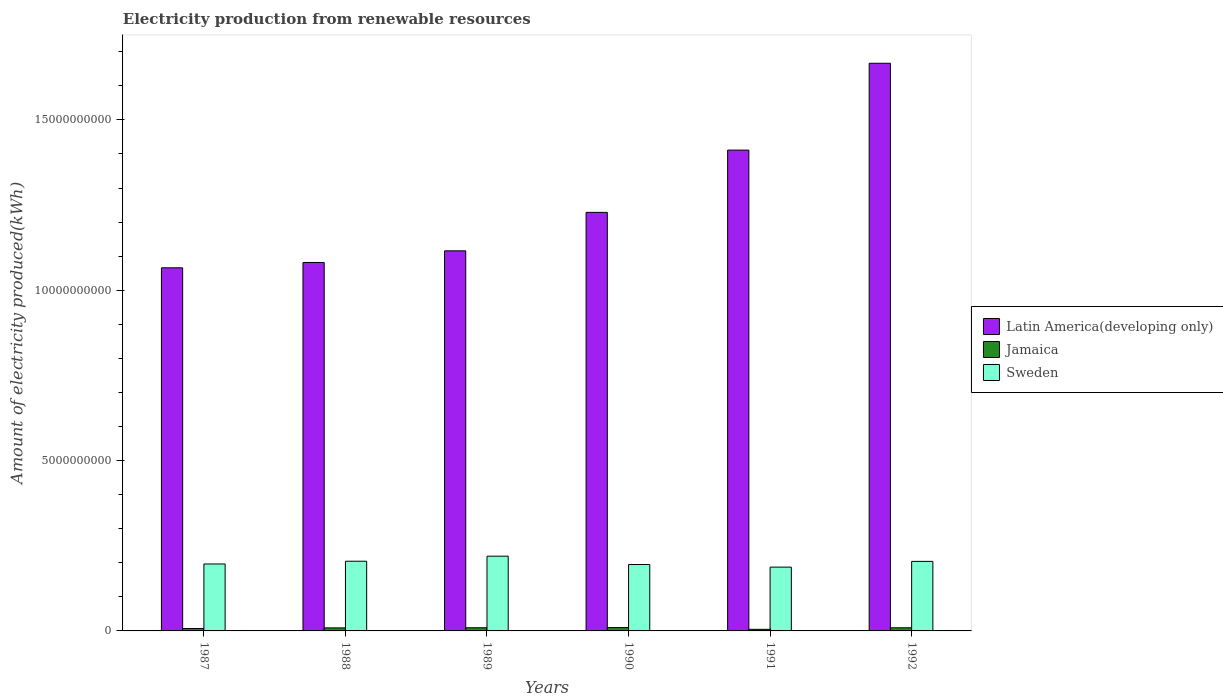Are the number of bars per tick equal to the number of legend labels?
Offer a very short reply. Yes. What is the label of the 3rd group of bars from the left?
Keep it short and to the point. 1989. In how many cases, is the number of bars for a given year not equal to the number of legend labels?
Your answer should be very brief. 0. What is the amount of electricity produced in Jamaica in 1987?
Offer a very short reply. 7.10e+07. Across all years, what is the maximum amount of electricity produced in Sweden?
Offer a very short reply. 2.19e+09. Across all years, what is the minimum amount of electricity produced in Jamaica?
Offer a very short reply. 4.70e+07. What is the total amount of electricity produced in Jamaica in the graph?
Offer a terse response. 4.90e+08. What is the difference between the amount of electricity produced in Sweden in 1988 and that in 1992?
Your response must be concise. 5.00e+06. What is the difference between the amount of electricity produced in Sweden in 1992 and the amount of electricity produced in Jamaica in 1987?
Make the answer very short. 1.97e+09. What is the average amount of electricity produced in Latin America(developing only) per year?
Offer a very short reply. 1.26e+1. In the year 1992, what is the difference between the amount of electricity produced in Latin America(developing only) and amount of electricity produced in Sweden?
Offer a very short reply. 1.46e+1. In how many years, is the amount of electricity produced in Sweden greater than 8000000000 kWh?
Keep it short and to the point. 0. What is the ratio of the amount of electricity produced in Sweden in 1989 to that in 1992?
Your response must be concise. 1.07. Is the amount of electricity produced in Jamaica in 1990 less than that in 1991?
Provide a short and direct response. No. What is the difference between the highest and the lowest amount of electricity produced in Latin America(developing only)?
Your answer should be compact. 6.00e+09. In how many years, is the amount of electricity produced in Jamaica greater than the average amount of electricity produced in Jamaica taken over all years?
Offer a terse response. 4. What does the 1st bar from the right in 1991 represents?
Your response must be concise. Sweden. What is the difference between two consecutive major ticks on the Y-axis?
Provide a short and direct response. 5.00e+09. Does the graph contain any zero values?
Give a very brief answer. No. How are the legend labels stacked?
Give a very brief answer. Vertical. What is the title of the graph?
Provide a succinct answer. Electricity production from renewable resources. What is the label or title of the X-axis?
Keep it short and to the point. Years. What is the label or title of the Y-axis?
Ensure brevity in your answer.  Amount of electricity produced(kWh). What is the Amount of electricity produced(kWh) in Latin America(developing only) in 1987?
Provide a short and direct response. 1.07e+1. What is the Amount of electricity produced(kWh) in Jamaica in 1987?
Offer a terse response. 7.10e+07. What is the Amount of electricity produced(kWh) of Sweden in 1987?
Make the answer very short. 1.96e+09. What is the Amount of electricity produced(kWh) of Latin America(developing only) in 1988?
Your answer should be very brief. 1.08e+1. What is the Amount of electricity produced(kWh) in Jamaica in 1988?
Offer a very short reply. 8.90e+07. What is the Amount of electricity produced(kWh) of Sweden in 1988?
Offer a terse response. 2.05e+09. What is the Amount of electricity produced(kWh) of Latin America(developing only) in 1989?
Give a very brief answer. 1.12e+1. What is the Amount of electricity produced(kWh) in Jamaica in 1989?
Provide a succinct answer. 9.30e+07. What is the Amount of electricity produced(kWh) of Sweden in 1989?
Your answer should be very brief. 2.19e+09. What is the Amount of electricity produced(kWh) of Latin America(developing only) in 1990?
Offer a very short reply. 1.23e+1. What is the Amount of electricity produced(kWh) of Jamaica in 1990?
Offer a terse response. 9.80e+07. What is the Amount of electricity produced(kWh) of Sweden in 1990?
Make the answer very short. 1.95e+09. What is the Amount of electricity produced(kWh) in Latin America(developing only) in 1991?
Offer a very short reply. 1.41e+1. What is the Amount of electricity produced(kWh) in Jamaica in 1991?
Your response must be concise. 4.70e+07. What is the Amount of electricity produced(kWh) in Sweden in 1991?
Your response must be concise. 1.87e+09. What is the Amount of electricity produced(kWh) of Latin America(developing only) in 1992?
Offer a very short reply. 1.67e+1. What is the Amount of electricity produced(kWh) in Jamaica in 1992?
Provide a short and direct response. 9.20e+07. What is the Amount of electricity produced(kWh) in Sweden in 1992?
Your response must be concise. 2.04e+09. Across all years, what is the maximum Amount of electricity produced(kWh) in Latin America(developing only)?
Ensure brevity in your answer.  1.67e+1. Across all years, what is the maximum Amount of electricity produced(kWh) in Jamaica?
Your response must be concise. 9.80e+07. Across all years, what is the maximum Amount of electricity produced(kWh) in Sweden?
Provide a short and direct response. 2.19e+09. Across all years, what is the minimum Amount of electricity produced(kWh) in Latin America(developing only)?
Make the answer very short. 1.07e+1. Across all years, what is the minimum Amount of electricity produced(kWh) of Jamaica?
Give a very brief answer. 4.70e+07. Across all years, what is the minimum Amount of electricity produced(kWh) of Sweden?
Your answer should be very brief. 1.87e+09. What is the total Amount of electricity produced(kWh) of Latin America(developing only) in the graph?
Your response must be concise. 7.57e+1. What is the total Amount of electricity produced(kWh) of Jamaica in the graph?
Make the answer very short. 4.90e+08. What is the total Amount of electricity produced(kWh) of Sweden in the graph?
Offer a very short reply. 1.21e+1. What is the difference between the Amount of electricity produced(kWh) in Latin America(developing only) in 1987 and that in 1988?
Your response must be concise. -1.56e+08. What is the difference between the Amount of electricity produced(kWh) in Jamaica in 1987 and that in 1988?
Give a very brief answer. -1.80e+07. What is the difference between the Amount of electricity produced(kWh) of Sweden in 1987 and that in 1988?
Provide a succinct answer. -8.10e+07. What is the difference between the Amount of electricity produced(kWh) in Latin America(developing only) in 1987 and that in 1989?
Your answer should be very brief. -4.98e+08. What is the difference between the Amount of electricity produced(kWh) of Jamaica in 1987 and that in 1989?
Offer a very short reply. -2.20e+07. What is the difference between the Amount of electricity produced(kWh) of Sweden in 1987 and that in 1989?
Offer a very short reply. -2.29e+08. What is the difference between the Amount of electricity produced(kWh) of Latin America(developing only) in 1987 and that in 1990?
Ensure brevity in your answer.  -1.63e+09. What is the difference between the Amount of electricity produced(kWh) in Jamaica in 1987 and that in 1990?
Your response must be concise. -2.70e+07. What is the difference between the Amount of electricity produced(kWh) of Sweden in 1987 and that in 1990?
Keep it short and to the point. 1.60e+07. What is the difference between the Amount of electricity produced(kWh) of Latin America(developing only) in 1987 and that in 1991?
Provide a short and direct response. -3.46e+09. What is the difference between the Amount of electricity produced(kWh) of Jamaica in 1987 and that in 1991?
Ensure brevity in your answer.  2.40e+07. What is the difference between the Amount of electricity produced(kWh) in Sweden in 1987 and that in 1991?
Offer a very short reply. 9.20e+07. What is the difference between the Amount of electricity produced(kWh) in Latin America(developing only) in 1987 and that in 1992?
Your answer should be very brief. -6.00e+09. What is the difference between the Amount of electricity produced(kWh) of Jamaica in 1987 and that in 1992?
Your response must be concise. -2.10e+07. What is the difference between the Amount of electricity produced(kWh) in Sweden in 1987 and that in 1992?
Your answer should be very brief. -7.60e+07. What is the difference between the Amount of electricity produced(kWh) of Latin America(developing only) in 1988 and that in 1989?
Your answer should be compact. -3.42e+08. What is the difference between the Amount of electricity produced(kWh) of Jamaica in 1988 and that in 1989?
Offer a terse response. -4.00e+06. What is the difference between the Amount of electricity produced(kWh) of Sweden in 1988 and that in 1989?
Your answer should be compact. -1.48e+08. What is the difference between the Amount of electricity produced(kWh) in Latin America(developing only) in 1988 and that in 1990?
Give a very brief answer. -1.47e+09. What is the difference between the Amount of electricity produced(kWh) of Jamaica in 1988 and that in 1990?
Offer a very short reply. -9.00e+06. What is the difference between the Amount of electricity produced(kWh) of Sweden in 1988 and that in 1990?
Your answer should be very brief. 9.70e+07. What is the difference between the Amount of electricity produced(kWh) of Latin America(developing only) in 1988 and that in 1991?
Offer a very short reply. -3.30e+09. What is the difference between the Amount of electricity produced(kWh) in Jamaica in 1988 and that in 1991?
Your answer should be very brief. 4.20e+07. What is the difference between the Amount of electricity produced(kWh) of Sweden in 1988 and that in 1991?
Provide a short and direct response. 1.73e+08. What is the difference between the Amount of electricity produced(kWh) in Latin America(developing only) in 1988 and that in 1992?
Your answer should be compact. -5.85e+09. What is the difference between the Amount of electricity produced(kWh) of Jamaica in 1988 and that in 1992?
Give a very brief answer. -3.00e+06. What is the difference between the Amount of electricity produced(kWh) of Latin America(developing only) in 1989 and that in 1990?
Give a very brief answer. -1.13e+09. What is the difference between the Amount of electricity produced(kWh) in Jamaica in 1989 and that in 1990?
Provide a succinct answer. -5.00e+06. What is the difference between the Amount of electricity produced(kWh) in Sweden in 1989 and that in 1990?
Offer a terse response. 2.45e+08. What is the difference between the Amount of electricity produced(kWh) of Latin America(developing only) in 1989 and that in 1991?
Provide a short and direct response. -2.96e+09. What is the difference between the Amount of electricity produced(kWh) in Jamaica in 1989 and that in 1991?
Provide a short and direct response. 4.60e+07. What is the difference between the Amount of electricity produced(kWh) in Sweden in 1989 and that in 1991?
Make the answer very short. 3.21e+08. What is the difference between the Amount of electricity produced(kWh) in Latin America(developing only) in 1989 and that in 1992?
Provide a succinct answer. -5.51e+09. What is the difference between the Amount of electricity produced(kWh) in Jamaica in 1989 and that in 1992?
Offer a very short reply. 1.00e+06. What is the difference between the Amount of electricity produced(kWh) in Sweden in 1989 and that in 1992?
Provide a succinct answer. 1.53e+08. What is the difference between the Amount of electricity produced(kWh) of Latin America(developing only) in 1990 and that in 1991?
Provide a short and direct response. -1.83e+09. What is the difference between the Amount of electricity produced(kWh) in Jamaica in 1990 and that in 1991?
Your answer should be compact. 5.10e+07. What is the difference between the Amount of electricity produced(kWh) of Sweden in 1990 and that in 1991?
Make the answer very short. 7.60e+07. What is the difference between the Amount of electricity produced(kWh) of Latin America(developing only) in 1990 and that in 1992?
Keep it short and to the point. -4.38e+09. What is the difference between the Amount of electricity produced(kWh) of Sweden in 1990 and that in 1992?
Your answer should be compact. -9.20e+07. What is the difference between the Amount of electricity produced(kWh) of Latin America(developing only) in 1991 and that in 1992?
Ensure brevity in your answer.  -2.55e+09. What is the difference between the Amount of electricity produced(kWh) of Jamaica in 1991 and that in 1992?
Provide a short and direct response. -4.50e+07. What is the difference between the Amount of electricity produced(kWh) of Sweden in 1991 and that in 1992?
Make the answer very short. -1.68e+08. What is the difference between the Amount of electricity produced(kWh) of Latin America(developing only) in 1987 and the Amount of electricity produced(kWh) of Jamaica in 1988?
Your answer should be very brief. 1.06e+1. What is the difference between the Amount of electricity produced(kWh) in Latin America(developing only) in 1987 and the Amount of electricity produced(kWh) in Sweden in 1988?
Provide a succinct answer. 8.61e+09. What is the difference between the Amount of electricity produced(kWh) of Jamaica in 1987 and the Amount of electricity produced(kWh) of Sweden in 1988?
Make the answer very short. -1.98e+09. What is the difference between the Amount of electricity produced(kWh) in Latin America(developing only) in 1987 and the Amount of electricity produced(kWh) in Jamaica in 1989?
Offer a very short reply. 1.06e+1. What is the difference between the Amount of electricity produced(kWh) in Latin America(developing only) in 1987 and the Amount of electricity produced(kWh) in Sweden in 1989?
Ensure brevity in your answer.  8.46e+09. What is the difference between the Amount of electricity produced(kWh) of Jamaica in 1987 and the Amount of electricity produced(kWh) of Sweden in 1989?
Ensure brevity in your answer.  -2.12e+09. What is the difference between the Amount of electricity produced(kWh) in Latin America(developing only) in 1987 and the Amount of electricity produced(kWh) in Jamaica in 1990?
Your answer should be very brief. 1.06e+1. What is the difference between the Amount of electricity produced(kWh) in Latin America(developing only) in 1987 and the Amount of electricity produced(kWh) in Sweden in 1990?
Your answer should be compact. 8.71e+09. What is the difference between the Amount of electricity produced(kWh) in Jamaica in 1987 and the Amount of electricity produced(kWh) in Sweden in 1990?
Keep it short and to the point. -1.88e+09. What is the difference between the Amount of electricity produced(kWh) in Latin America(developing only) in 1987 and the Amount of electricity produced(kWh) in Jamaica in 1991?
Make the answer very short. 1.06e+1. What is the difference between the Amount of electricity produced(kWh) in Latin America(developing only) in 1987 and the Amount of electricity produced(kWh) in Sweden in 1991?
Offer a terse response. 8.79e+09. What is the difference between the Amount of electricity produced(kWh) in Jamaica in 1987 and the Amount of electricity produced(kWh) in Sweden in 1991?
Give a very brief answer. -1.80e+09. What is the difference between the Amount of electricity produced(kWh) in Latin America(developing only) in 1987 and the Amount of electricity produced(kWh) in Jamaica in 1992?
Keep it short and to the point. 1.06e+1. What is the difference between the Amount of electricity produced(kWh) in Latin America(developing only) in 1987 and the Amount of electricity produced(kWh) in Sweden in 1992?
Give a very brief answer. 8.62e+09. What is the difference between the Amount of electricity produced(kWh) of Jamaica in 1987 and the Amount of electricity produced(kWh) of Sweden in 1992?
Your response must be concise. -1.97e+09. What is the difference between the Amount of electricity produced(kWh) of Latin America(developing only) in 1988 and the Amount of electricity produced(kWh) of Jamaica in 1989?
Offer a very short reply. 1.07e+1. What is the difference between the Amount of electricity produced(kWh) of Latin America(developing only) in 1988 and the Amount of electricity produced(kWh) of Sweden in 1989?
Your response must be concise. 8.62e+09. What is the difference between the Amount of electricity produced(kWh) in Jamaica in 1988 and the Amount of electricity produced(kWh) in Sweden in 1989?
Your response must be concise. -2.10e+09. What is the difference between the Amount of electricity produced(kWh) of Latin America(developing only) in 1988 and the Amount of electricity produced(kWh) of Jamaica in 1990?
Ensure brevity in your answer.  1.07e+1. What is the difference between the Amount of electricity produced(kWh) of Latin America(developing only) in 1988 and the Amount of electricity produced(kWh) of Sweden in 1990?
Offer a very short reply. 8.87e+09. What is the difference between the Amount of electricity produced(kWh) of Jamaica in 1988 and the Amount of electricity produced(kWh) of Sweden in 1990?
Provide a short and direct response. -1.86e+09. What is the difference between the Amount of electricity produced(kWh) in Latin America(developing only) in 1988 and the Amount of electricity produced(kWh) in Jamaica in 1991?
Give a very brief answer. 1.08e+1. What is the difference between the Amount of electricity produced(kWh) of Latin America(developing only) in 1988 and the Amount of electricity produced(kWh) of Sweden in 1991?
Make the answer very short. 8.94e+09. What is the difference between the Amount of electricity produced(kWh) of Jamaica in 1988 and the Amount of electricity produced(kWh) of Sweden in 1991?
Your answer should be very brief. -1.78e+09. What is the difference between the Amount of electricity produced(kWh) of Latin America(developing only) in 1988 and the Amount of electricity produced(kWh) of Jamaica in 1992?
Your response must be concise. 1.07e+1. What is the difference between the Amount of electricity produced(kWh) of Latin America(developing only) in 1988 and the Amount of electricity produced(kWh) of Sweden in 1992?
Your response must be concise. 8.77e+09. What is the difference between the Amount of electricity produced(kWh) of Jamaica in 1988 and the Amount of electricity produced(kWh) of Sweden in 1992?
Your answer should be very brief. -1.95e+09. What is the difference between the Amount of electricity produced(kWh) of Latin America(developing only) in 1989 and the Amount of electricity produced(kWh) of Jamaica in 1990?
Your answer should be compact. 1.11e+1. What is the difference between the Amount of electricity produced(kWh) of Latin America(developing only) in 1989 and the Amount of electricity produced(kWh) of Sweden in 1990?
Your answer should be compact. 9.21e+09. What is the difference between the Amount of electricity produced(kWh) of Jamaica in 1989 and the Amount of electricity produced(kWh) of Sweden in 1990?
Your response must be concise. -1.86e+09. What is the difference between the Amount of electricity produced(kWh) of Latin America(developing only) in 1989 and the Amount of electricity produced(kWh) of Jamaica in 1991?
Provide a succinct answer. 1.11e+1. What is the difference between the Amount of electricity produced(kWh) of Latin America(developing only) in 1989 and the Amount of electricity produced(kWh) of Sweden in 1991?
Give a very brief answer. 9.28e+09. What is the difference between the Amount of electricity produced(kWh) in Jamaica in 1989 and the Amount of electricity produced(kWh) in Sweden in 1991?
Offer a terse response. -1.78e+09. What is the difference between the Amount of electricity produced(kWh) in Latin America(developing only) in 1989 and the Amount of electricity produced(kWh) in Jamaica in 1992?
Your answer should be very brief. 1.11e+1. What is the difference between the Amount of electricity produced(kWh) in Latin America(developing only) in 1989 and the Amount of electricity produced(kWh) in Sweden in 1992?
Offer a terse response. 9.12e+09. What is the difference between the Amount of electricity produced(kWh) of Jamaica in 1989 and the Amount of electricity produced(kWh) of Sweden in 1992?
Your answer should be very brief. -1.95e+09. What is the difference between the Amount of electricity produced(kWh) of Latin America(developing only) in 1990 and the Amount of electricity produced(kWh) of Jamaica in 1991?
Your answer should be compact. 1.22e+1. What is the difference between the Amount of electricity produced(kWh) of Latin America(developing only) in 1990 and the Amount of electricity produced(kWh) of Sweden in 1991?
Your response must be concise. 1.04e+1. What is the difference between the Amount of electricity produced(kWh) in Jamaica in 1990 and the Amount of electricity produced(kWh) in Sweden in 1991?
Offer a very short reply. -1.78e+09. What is the difference between the Amount of electricity produced(kWh) in Latin America(developing only) in 1990 and the Amount of electricity produced(kWh) in Jamaica in 1992?
Your answer should be compact. 1.22e+1. What is the difference between the Amount of electricity produced(kWh) in Latin America(developing only) in 1990 and the Amount of electricity produced(kWh) in Sweden in 1992?
Your answer should be very brief. 1.02e+1. What is the difference between the Amount of electricity produced(kWh) in Jamaica in 1990 and the Amount of electricity produced(kWh) in Sweden in 1992?
Ensure brevity in your answer.  -1.94e+09. What is the difference between the Amount of electricity produced(kWh) in Latin America(developing only) in 1991 and the Amount of electricity produced(kWh) in Jamaica in 1992?
Make the answer very short. 1.40e+1. What is the difference between the Amount of electricity produced(kWh) in Latin America(developing only) in 1991 and the Amount of electricity produced(kWh) in Sweden in 1992?
Provide a short and direct response. 1.21e+1. What is the difference between the Amount of electricity produced(kWh) in Jamaica in 1991 and the Amount of electricity produced(kWh) in Sweden in 1992?
Offer a very short reply. -1.99e+09. What is the average Amount of electricity produced(kWh) of Latin America(developing only) per year?
Make the answer very short. 1.26e+1. What is the average Amount of electricity produced(kWh) of Jamaica per year?
Give a very brief answer. 8.17e+07. What is the average Amount of electricity produced(kWh) of Sweden per year?
Offer a terse response. 2.01e+09. In the year 1987, what is the difference between the Amount of electricity produced(kWh) in Latin America(developing only) and Amount of electricity produced(kWh) in Jamaica?
Your response must be concise. 1.06e+1. In the year 1987, what is the difference between the Amount of electricity produced(kWh) of Latin America(developing only) and Amount of electricity produced(kWh) of Sweden?
Keep it short and to the point. 8.69e+09. In the year 1987, what is the difference between the Amount of electricity produced(kWh) in Jamaica and Amount of electricity produced(kWh) in Sweden?
Ensure brevity in your answer.  -1.89e+09. In the year 1988, what is the difference between the Amount of electricity produced(kWh) in Latin America(developing only) and Amount of electricity produced(kWh) in Jamaica?
Offer a terse response. 1.07e+1. In the year 1988, what is the difference between the Amount of electricity produced(kWh) of Latin America(developing only) and Amount of electricity produced(kWh) of Sweden?
Your answer should be compact. 8.77e+09. In the year 1988, what is the difference between the Amount of electricity produced(kWh) in Jamaica and Amount of electricity produced(kWh) in Sweden?
Your answer should be compact. -1.96e+09. In the year 1989, what is the difference between the Amount of electricity produced(kWh) in Latin America(developing only) and Amount of electricity produced(kWh) in Jamaica?
Your response must be concise. 1.11e+1. In the year 1989, what is the difference between the Amount of electricity produced(kWh) of Latin America(developing only) and Amount of electricity produced(kWh) of Sweden?
Your response must be concise. 8.96e+09. In the year 1989, what is the difference between the Amount of electricity produced(kWh) in Jamaica and Amount of electricity produced(kWh) in Sweden?
Ensure brevity in your answer.  -2.10e+09. In the year 1990, what is the difference between the Amount of electricity produced(kWh) in Latin America(developing only) and Amount of electricity produced(kWh) in Jamaica?
Your response must be concise. 1.22e+1. In the year 1990, what is the difference between the Amount of electricity produced(kWh) of Latin America(developing only) and Amount of electricity produced(kWh) of Sweden?
Your response must be concise. 1.03e+1. In the year 1990, what is the difference between the Amount of electricity produced(kWh) of Jamaica and Amount of electricity produced(kWh) of Sweden?
Provide a succinct answer. -1.85e+09. In the year 1991, what is the difference between the Amount of electricity produced(kWh) of Latin America(developing only) and Amount of electricity produced(kWh) of Jamaica?
Your answer should be compact. 1.41e+1. In the year 1991, what is the difference between the Amount of electricity produced(kWh) in Latin America(developing only) and Amount of electricity produced(kWh) in Sweden?
Keep it short and to the point. 1.22e+1. In the year 1991, what is the difference between the Amount of electricity produced(kWh) of Jamaica and Amount of electricity produced(kWh) of Sweden?
Offer a terse response. -1.83e+09. In the year 1992, what is the difference between the Amount of electricity produced(kWh) of Latin America(developing only) and Amount of electricity produced(kWh) of Jamaica?
Offer a terse response. 1.66e+1. In the year 1992, what is the difference between the Amount of electricity produced(kWh) in Latin America(developing only) and Amount of electricity produced(kWh) in Sweden?
Make the answer very short. 1.46e+1. In the year 1992, what is the difference between the Amount of electricity produced(kWh) in Jamaica and Amount of electricity produced(kWh) in Sweden?
Provide a succinct answer. -1.95e+09. What is the ratio of the Amount of electricity produced(kWh) in Latin America(developing only) in 1987 to that in 1988?
Offer a very short reply. 0.99. What is the ratio of the Amount of electricity produced(kWh) of Jamaica in 1987 to that in 1988?
Provide a succinct answer. 0.8. What is the ratio of the Amount of electricity produced(kWh) of Sweden in 1987 to that in 1988?
Offer a very short reply. 0.96. What is the ratio of the Amount of electricity produced(kWh) in Latin America(developing only) in 1987 to that in 1989?
Provide a short and direct response. 0.96. What is the ratio of the Amount of electricity produced(kWh) of Jamaica in 1987 to that in 1989?
Offer a terse response. 0.76. What is the ratio of the Amount of electricity produced(kWh) of Sweden in 1987 to that in 1989?
Provide a succinct answer. 0.9. What is the ratio of the Amount of electricity produced(kWh) of Latin America(developing only) in 1987 to that in 1990?
Ensure brevity in your answer.  0.87. What is the ratio of the Amount of electricity produced(kWh) in Jamaica in 1987 to that in 1990?
Offer a very short reply. 0.72. What is the ratio of the Amount of electricity produced(kWh) of Sweden in 1987 to that in 1990?
Keep it short and to the point. 1.01. What is the ratio of the Amount of electricity produced(kWh) of Latin America(developing only) in 1987 to that in 1991?
Offer a terse response. 0.76. What is the ratio of the Amount of electricity produced(kWh) of Jamaica in 1987 to that in 1991?
Ensure brevity in your answer.  1.51. What is the ratio of the Amount of electricity produced(kWh) in Sweden in 1987 to that in 1991?
Offer a very short reply. 1.05. What is the ratio of the Amount of electricity produced(kWh) in Latin America(developing only) in 1987 to that in 1992?
Your response must be concise. 0.64. What is the ratio of the Amount of electricity produced(kWh) of Jamaica in 1987 to that in 1992?
Make the answer very short. 0.77. What is the ratio of the Amount of electricity produced(kWh) of Sweden in 1987 to that in 1992?
Provide a succinct answer. 0.96. What is the ratio of the Amount of electricity produced(kWh) in Latin America(developing only) in 1988 to that in 1989?
Make the answer very short. 0.97. What is the ratio of the Amount of electricity produced(kWh) in Sweden in 1988 to that in 1989?
Ensure brevity in your answer.  0.93. What is the ratio of the Amount of electricity produced(kWh) in Latin America(developing only) in 1988 to that in 1990?
Offer a terse response. 0.88. What is the ratio of the Amount of electricity produced(kWh) of Jamaica in 1988 to that in 1990?
Your answer should be compact. 0.91. What is the ratio of the Amount of electricity produced(kWh) in Sweden in 1988 to that in 1990?
Offer a very short reply. 1.05. What is the ratio of the Amount of electricity produced(kWh) of Latin America(developing only) in 1988 to that in 1991?
Give a very brief answer. 0.77. What is the ratio of the Amount of electricity produced(kWh) in Jamaica in 1988 to that in 1991?
Keep it short and to the point. 1.89. What is the ratio of the Amount of electricity produced(kWh) in Sweden in 1988 to that in 1991?
Ensure brevity in your answer.  1.09. What is the ratio of the Amount of electricity produced(kWh) in Latin America(developing only) in 1988 to that in 1992?
Your response must be concise. 0.65. What is the ratio of the Amount of electricity produced(kWh) of Jamaica in 1988 to that in 1992?
Your response must be concise. 0.97. What is the ratio of the Amount of electricity produced(kWh) in Latin America(developing only) in 1989 to that in 1990?
Give a very brief answer. 0.91. What is the ratio of the Amount of electricity produced(kWh) in Jamaica in 1989 to that in 1990?
Your answer should be compact. 0.95. What is the ratio of the Amount of electricity produced(kWh) of Sweden in 1989 to that in 1990?
Give a very brief answer. 1.13. What is the ratio of the Amount of electricity produced(kWh) of Latin America(developing only) in 1989 to that in 1991?
Make the answer very short. 0.79. What is the ratio of the Amount of electricity produced(kWh) of Jamaica in 1989 to that in 1991?
Your answer should be compact. 1.98. What is the ratio of the Amount of electricity produced(kWh) of Sweden in 1989 to that in 1991?
Your response must be concise. 1.17. What is the ratio of the Amount of electricity produced(kWh) in Latin America(developing only) in 1989 to that in 1992?
Provide a succinct answer. 0.67. What is the ratio of the Amount of electricity produced(kWh) of Jamaica in 1989 to that in 1992?
Give a very brief answer. 1.01. What is the ratio of the Amount of electricity produced(kWh) in Sweden in 1989 to that in 1992?
Offer a terse response. 1.07. What is the ratio of the Amount of electricity produced(kWh) of Latin America(developing only) in 1990 to that in 1991?
Your answer should be very brief. 0.87. What is the ratio of the Amount of electricity produced(kWh) of Jamaica in 1990 to that in 1991?
Provide a short and direct response. 2.09. What is the ratio of the Amount of electricity produced(kWh) of Sweden in 1990 to that in 1991?
Make the answer very short. 1.04. What is the ratio of the Amount of electricity produced(kWh) in Latin America(developing only) in 1990 to that in 1992?
Give a very brief answer. 0.74. What is the ratio of the Amount of electricity produced(kWh) of Jamaica in 1990 to that in 1992?
Offer a very short reply. 1.07. What is the ratio of the Amount of electricity produced(kWh) of Sweden in 1990 to that in 1992?
Your response must be concise. 0.95. What is the ratio of the Amount of electricity produced(kWh) of Latin America(developing only) in 1991 to that in 1992?
Keep it short and to the point. 0.85. What is the ratio of the Amount of electricity produced(kWh) of Jamaica in 1991 to that in 1992?
Provide a succinct answer. 0.51. What is the ratio of the Amount of electricity produced(kWh) of Sweden in 1991 to that in 1992?
Your answer should be compact. 0.92. What is the difference between the highest and the second highest Amount of electricity produced(kWh) in Latin America(developing only)?
Offer a very short reply. 2.55e+09. What is the difference between the highest and the second highest Amount of electricity produced(kWh) in Jamaica?
Your answer should be compact. 5.00e+06. What is the difference between the highest and the second highest Amount of electricity produced(kWh) in Sweden?
Make the answer very short. 1.48e+08. What is the difference between the highest and the lowest Amount of electricity produced(kWh) in Latin America(developing only)?
Give a very brief answer. 6.00e+09. What is the difference between the highest and the lowest Amount of electricity produced(kWh) of Jamaica?
Offer a terse response. 5.10e+07. What is the difference between the highest and the lowest Amount of electricity produced(kWh) in Sweden?
Provide a succinct answer. 3.21e+08. 